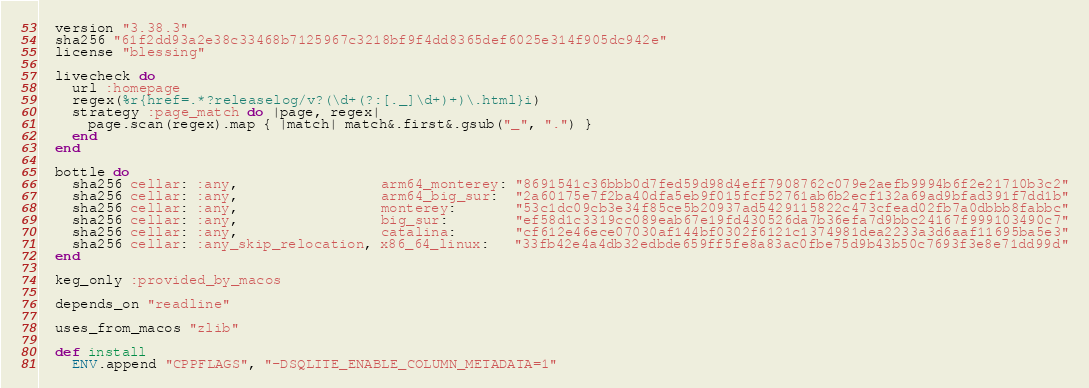Convert code to text. <code><loc_0><loc_0><loc_500><loc_500><_Ruby_>  version "3.38.3"
  sha256 "61f2dd93a2e38c33468b7125967c3218bf9f4dd8365def6025e314f905dc942e"
  license "blessing"

  livecheck do
    url :homepage
    regex(%r{href=.*?releaselog/v?(\d+(?:[._]\d+)+)\.html}i)
    strategy :page_match do |page, regex|
      page.scan(regex).map { |match| match&.first&.gsub("_", ".") }
    end
  end

  bottle do
    sha256 cellar: :any,                 arm64_monterey: "8691541c36bbb0d7fed59d98d4eff7908762c079e2aefb9994b6f2e21710b3c2"
    sha256 cellar: :any,                 arm64_big_sur:  "2a60175e7f2ba40dfa5eb9f015fcf52761ab6b2ecf132a69ad9bfad391f7dd1b"
    sha256 cellar: :any,                 monterey:       "53c1dc09cb3e34f85ce5b20937ad5429115822c473cfead02fb7a0dbbb8fabbc"
    sha256 cellar: :any,                 big_sur:        "ef58d1c3319cc089eab67e19fd430526da7b36efa7d9bbc24167f999103490c7"
    sha256 cellar: :any,                 catalina:       "cf612e46ece07030af144bf0302f6121c1374981dea2233a3d6aaf11695ba5e3"
    sha256 cellar: :any_skip_relocation, x86_64_linux:   "33fb42e4a4db32edbde659ff5fe8a83ac0fbe75d9b43b50c7693f3e8e71dd99d"
  end

  keg_only :provided_by_macos

  depends_on "readline"

  uses_from_macos "zlib"

  def install
    ENV.append "CPPFLAGS", "-DSQLITE_ENABLE_COLUMN_METADATA=1"</code> 